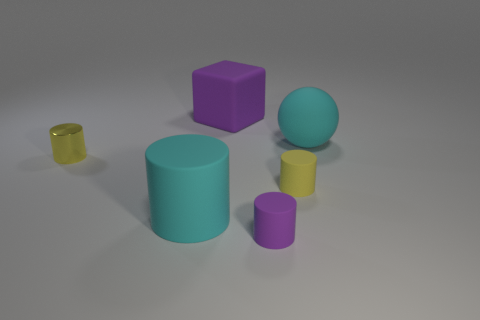Add 4 large green rubber things. How many objects exist? 10 Subtract all small yellow metal cylinders. How many cylinders are left? 3 Add 1 yellow rubber cylinders. How many yellow rubber cylinders are left? 2 Add 1 small yellow metallic cylinders. How many small yellow metallic cylinders exist? 2 Subtract all cyan cylinders. How many cylinders are left? 3 Subtract 0 green blocks. How many objects are left? 6 Subtract all cubes. How many objects are left? 5 Subtract 1 spheres. How many spheres are left? 0 Subtract all brown cylinders. Subtract all cyan balls. How many cylinders are left? 4 Subtract all cyan cylinders. How many red blocks are left? 0 